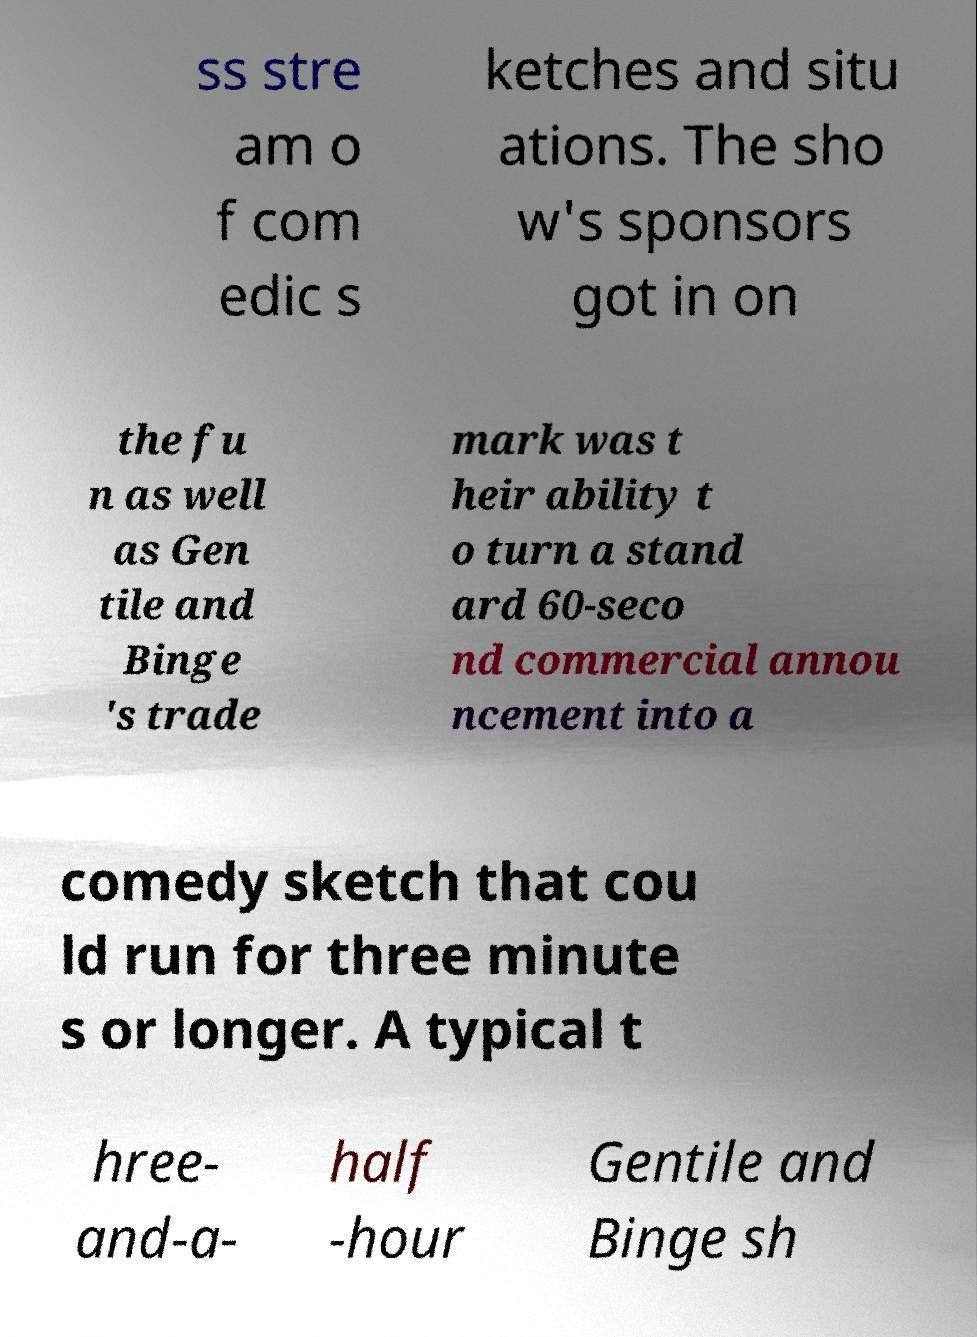Please identify and transcribe the text found in this image. ss stre am o f com edic s ketches and situ ations. The sho w's sponsors got in on the fu n as well as Gen tile and Binge 's trade mark was t heir ability t o turn a stand ard 60-seco nd commercial annou ncement into a comedy sketch that cou ld run for three minute s or longer. A typical t hree- and-a- half -hour Gentile and Binge sh 